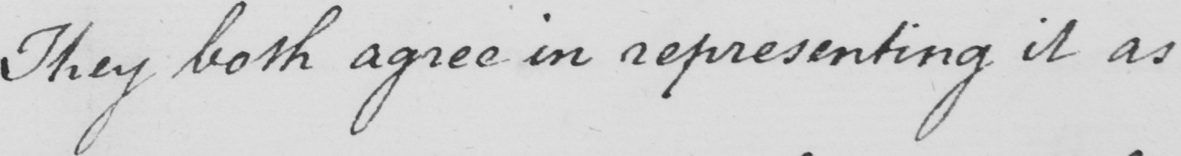What text is written in this handwritten line? They both agree in representing it as 